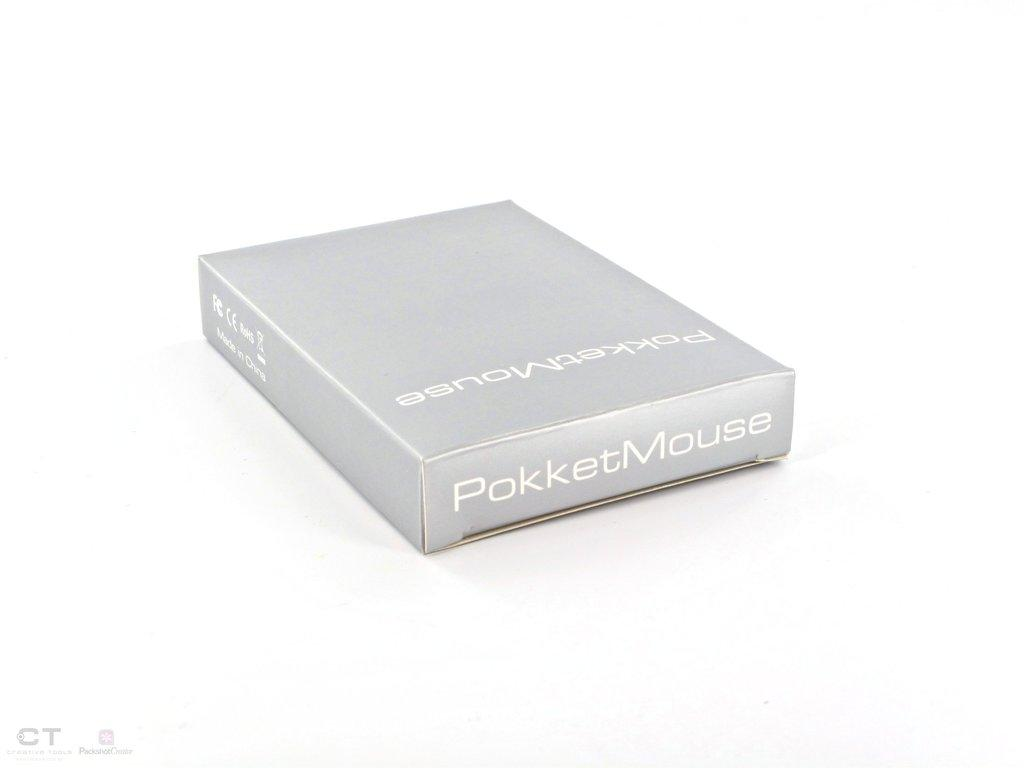<image>
Create a compact narrative representing the image presented. A PokketMouse package sitting in a white background. 